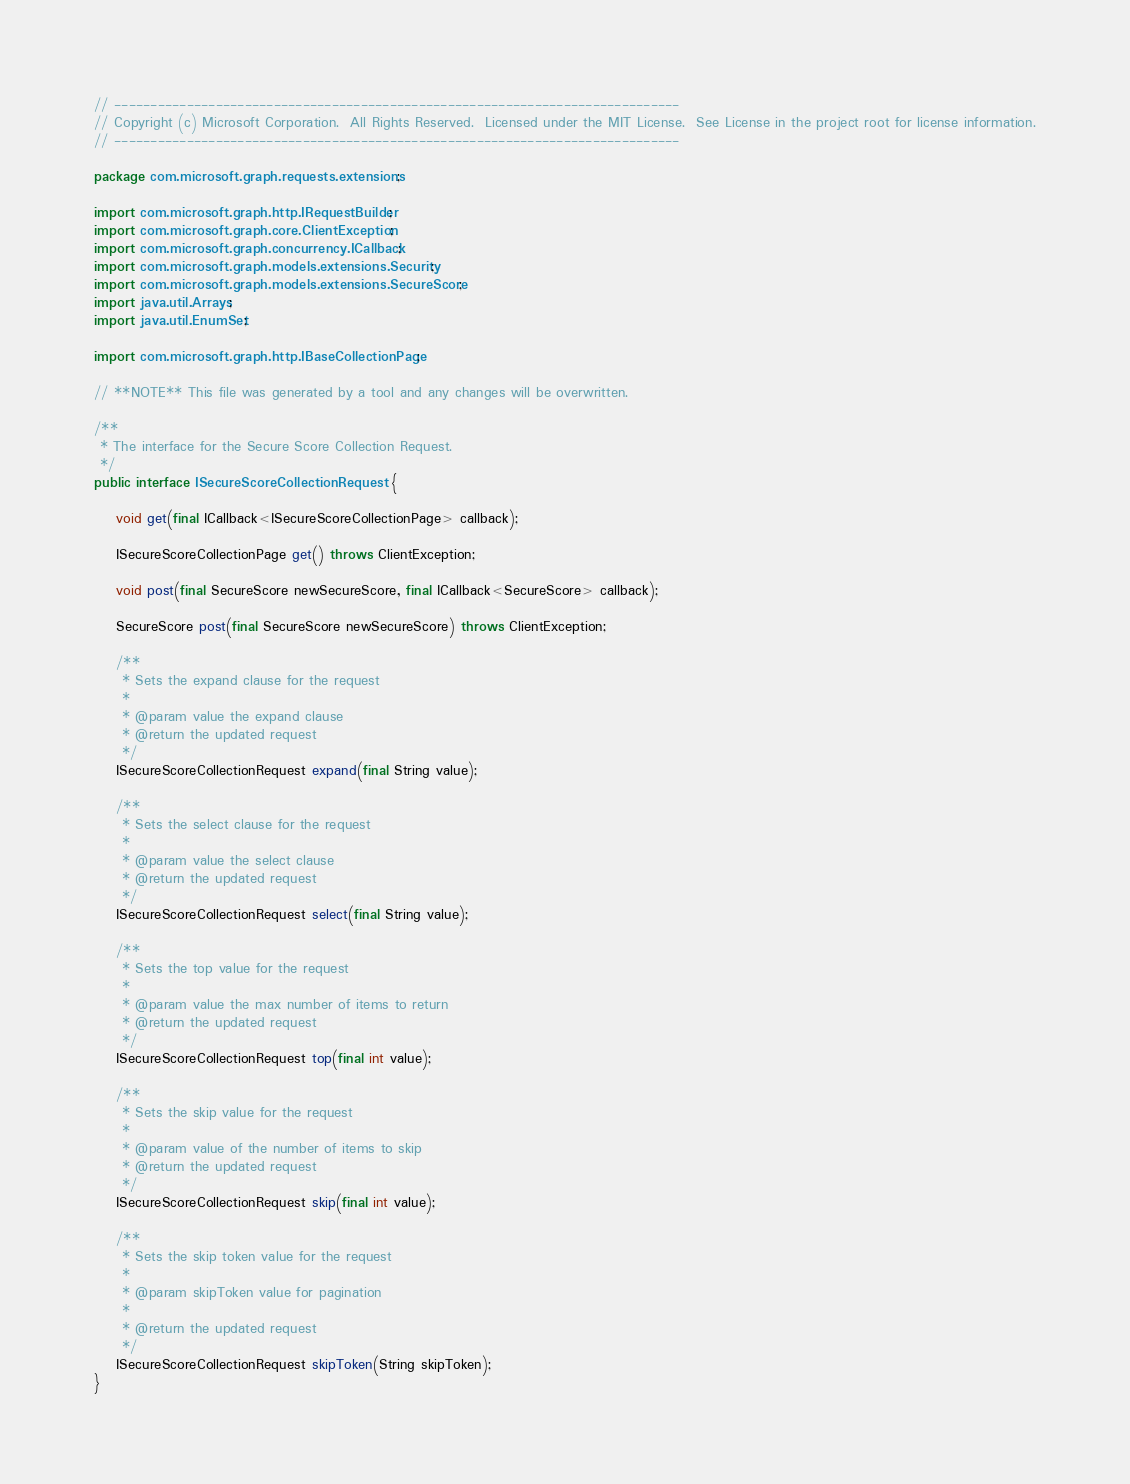Convert code to text. <code><loc_0><loc_0><loc_500><loc_500><_Java_>// ------------------------------------------------------------------------------
// Copyright (c) Microsoft Corporation.  All Rights Reserved.  Licensed under the MIT License.  See License in the project root for license information.
// ------------------------------------------------------------------------------

package com.microsoft.graph.requests.extensions;

import com.microsoft.graph.http.IRequestBuilder;
import com.microsoft.graph.core.ClientException;
import com.microsoft.graph.concurrency.ICallback;
import com.microsoft.graph.models.extensions.Security;
import com.microsoft.graph.models.extensions.SecureScore;
import java.util.Arrays;
import java.util.EnumSet;

import com.microsoft.graph.http.IBaseCollectionPage;

// **NOTE** This file was generated by a tool and any changes will be overwritten.

/**
 * The interface for the Secure Score Collection Request.
 */
public interface ISecureScoreCollectionRequest {

    void get(final ICallback<ISecureScoreCollectionPage> callback);

    ISecureScoreCollectionPage get() throws ClientException;

    void post(final SecureScore newSecureScore, final ICallback<SecureScore> callback);

    SecureScore post(final SecureScore newSecureScore) throws ClientException;

    /**
     * Sets the expand clause for the request
     *
     * @param value the expand clause
     * @return the updated request
     */
    ISecureScoreCollectionRequest expand(final String value);

    /**
     * Sets the select clause for the request
     *
     * @param value the select clause
     * @return the updated request
     */
    ISecureScoreCollectionRequest select(final String value);

    /**
     * Sets the top value for the request
     *
     * @param value the max number of items to return
     * @return the updated request
     */
    ISecureScoreCollectionRequest top(final int value);

    /**
     * Sets the skip value for the request
     *
     * @param value of the number of items to skip
     * @return the updated request
     */
    ISecureScoreCollectionRequest skip(final int value);

    /**
	 * Sets the skip token value for the request
	 * 
	 * @param skipToken value for pagination
     *
	 * @return the updated request
	 */
	ISecureScoreCollectionRequest skipToken(String skipToken);
}
</code> 